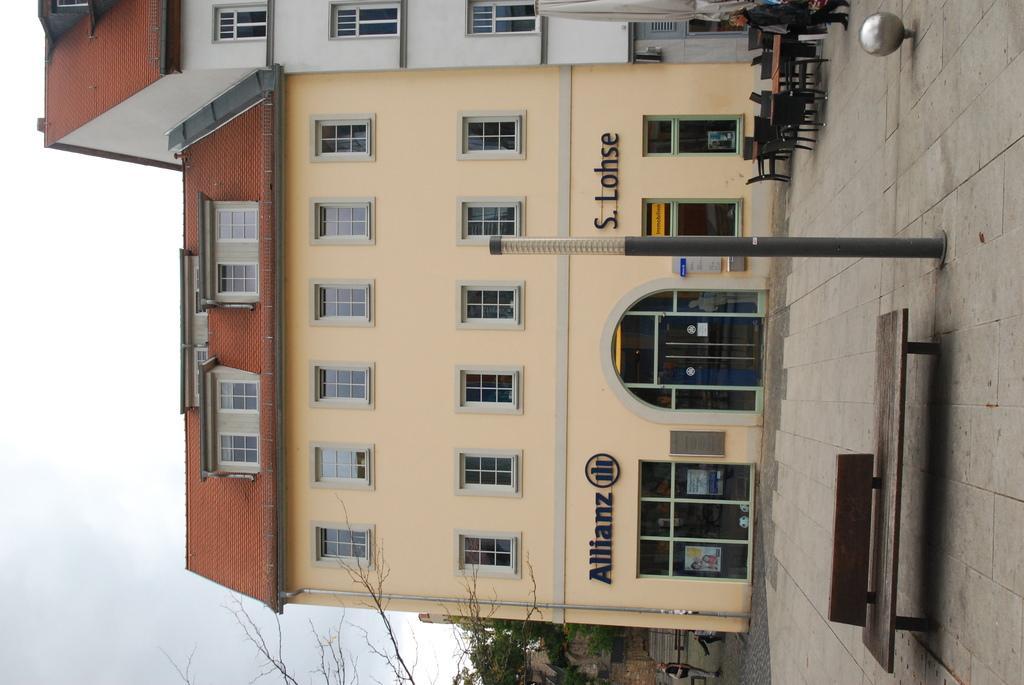In one or two sentences, can you explain what this image depicts? In this image I can see the ground, a bench, a pole, few chairs, a table, a person standing, few trees and few buildings. In the background I can see the sky. 